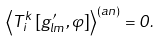<formula> <loc_0><loc_0><loc_500><loc_500>\left \langle T _ { i } ^ { k } \left [ g ^ { \prime } _ { l m } , \varphi \right ] \right \rangle ^ { ( a n ) } = 0 .</formula> 